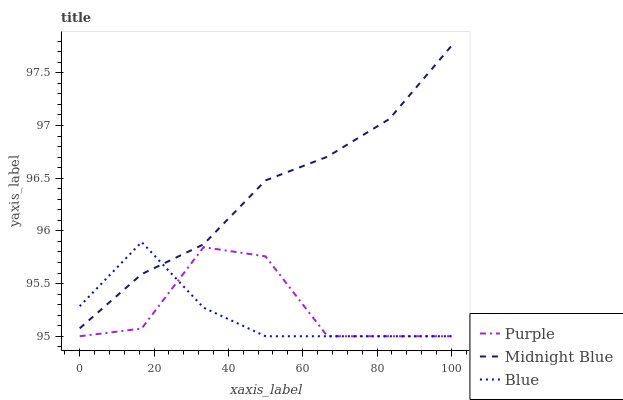Does Blue have the minimum area under the curve?
Answer yes or no. Yes. Does Midnight Blue have the maximum area under the curve?
Answer yes or no. Yes. Does Midnight Blue have the minimum area under the curve?
Answer yes or no. No. Does Blue have the maximum area under the curve?
Answer yes or no. No. Is Midnight Blue the smoothest?
Answer yes or no. Yes. Is Purple the roughest?
Answer yes or no. Yes. Is Blue the smoothest?
Answer yes or no. No. Is Blue the roughest?
Answer yes or no. No. Does Midnight Blue have the lowest value?
Answer yes or no. No. Does Midnight Blue have the highest value?
Answer yes or no. Yes. Does Blue have the highest value?
Answer yes or no. No. Is Purple less than Midnight Blue?
Answer yes or no. Yes. Is Midnight Blue greater than Purple?
Answer yes or no. Yes. Does Blue intersect Midnight Blue?
Answer yes or no. Yes. Is Blue less than Midnight Blue?
Answer yes or no. No. Is Blue greater than Midnight Blue?
Answer yes or no. No. Does Purple intersect Midnight Blue?
Answer yes or no. No. 